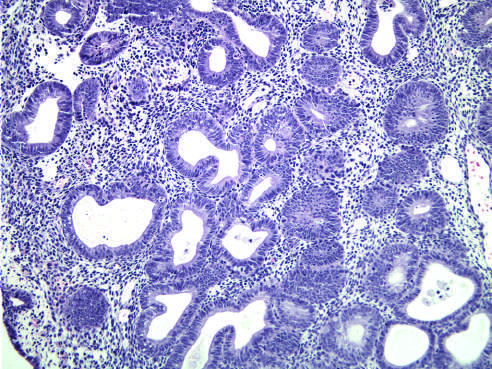s endoscopic view of a longitudinally-oriented mallory-weiss characterized by nests of closely packed glands?
Answer the question using a single word or phrase. No 